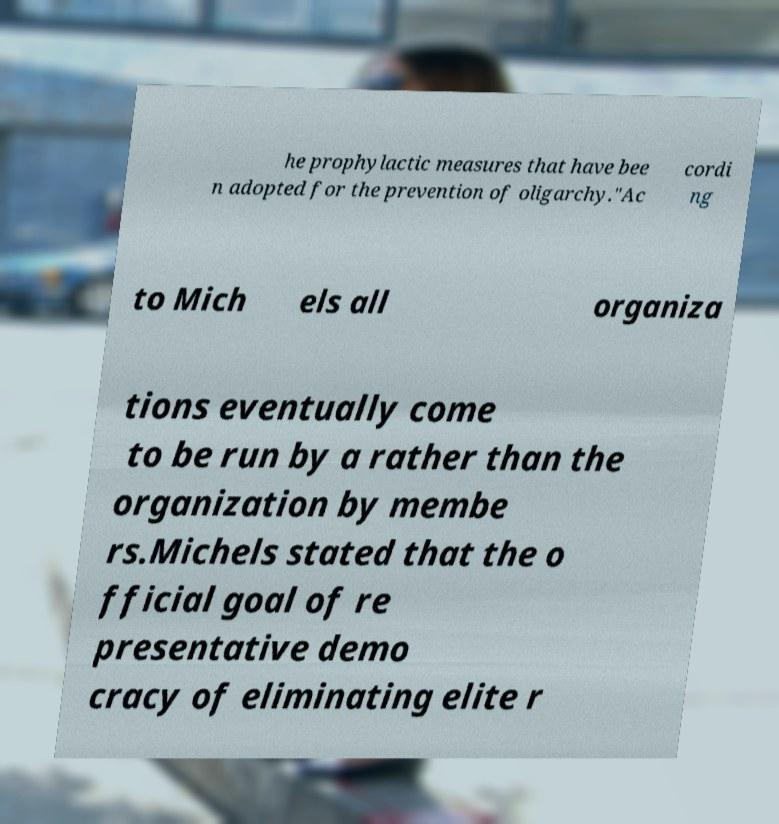What messages or text are displayed in this image? I need them in a readable, typed format. he prophylactic measures that have bee n adopted for the prevention of oligarchy."Ac cordi ng to Mich els all organiza tions eventually come to be run by a rather than the organization by membe rs.Michels stated that the o fficial goal of re presentative demo cracy of eliminating elite r 